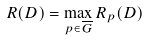<formula> <loc_0><loc_0><loc_500><loc_500>R ( D ) = \max _ { p \in \overline { G } } R _ { p } ( D )</formula> 